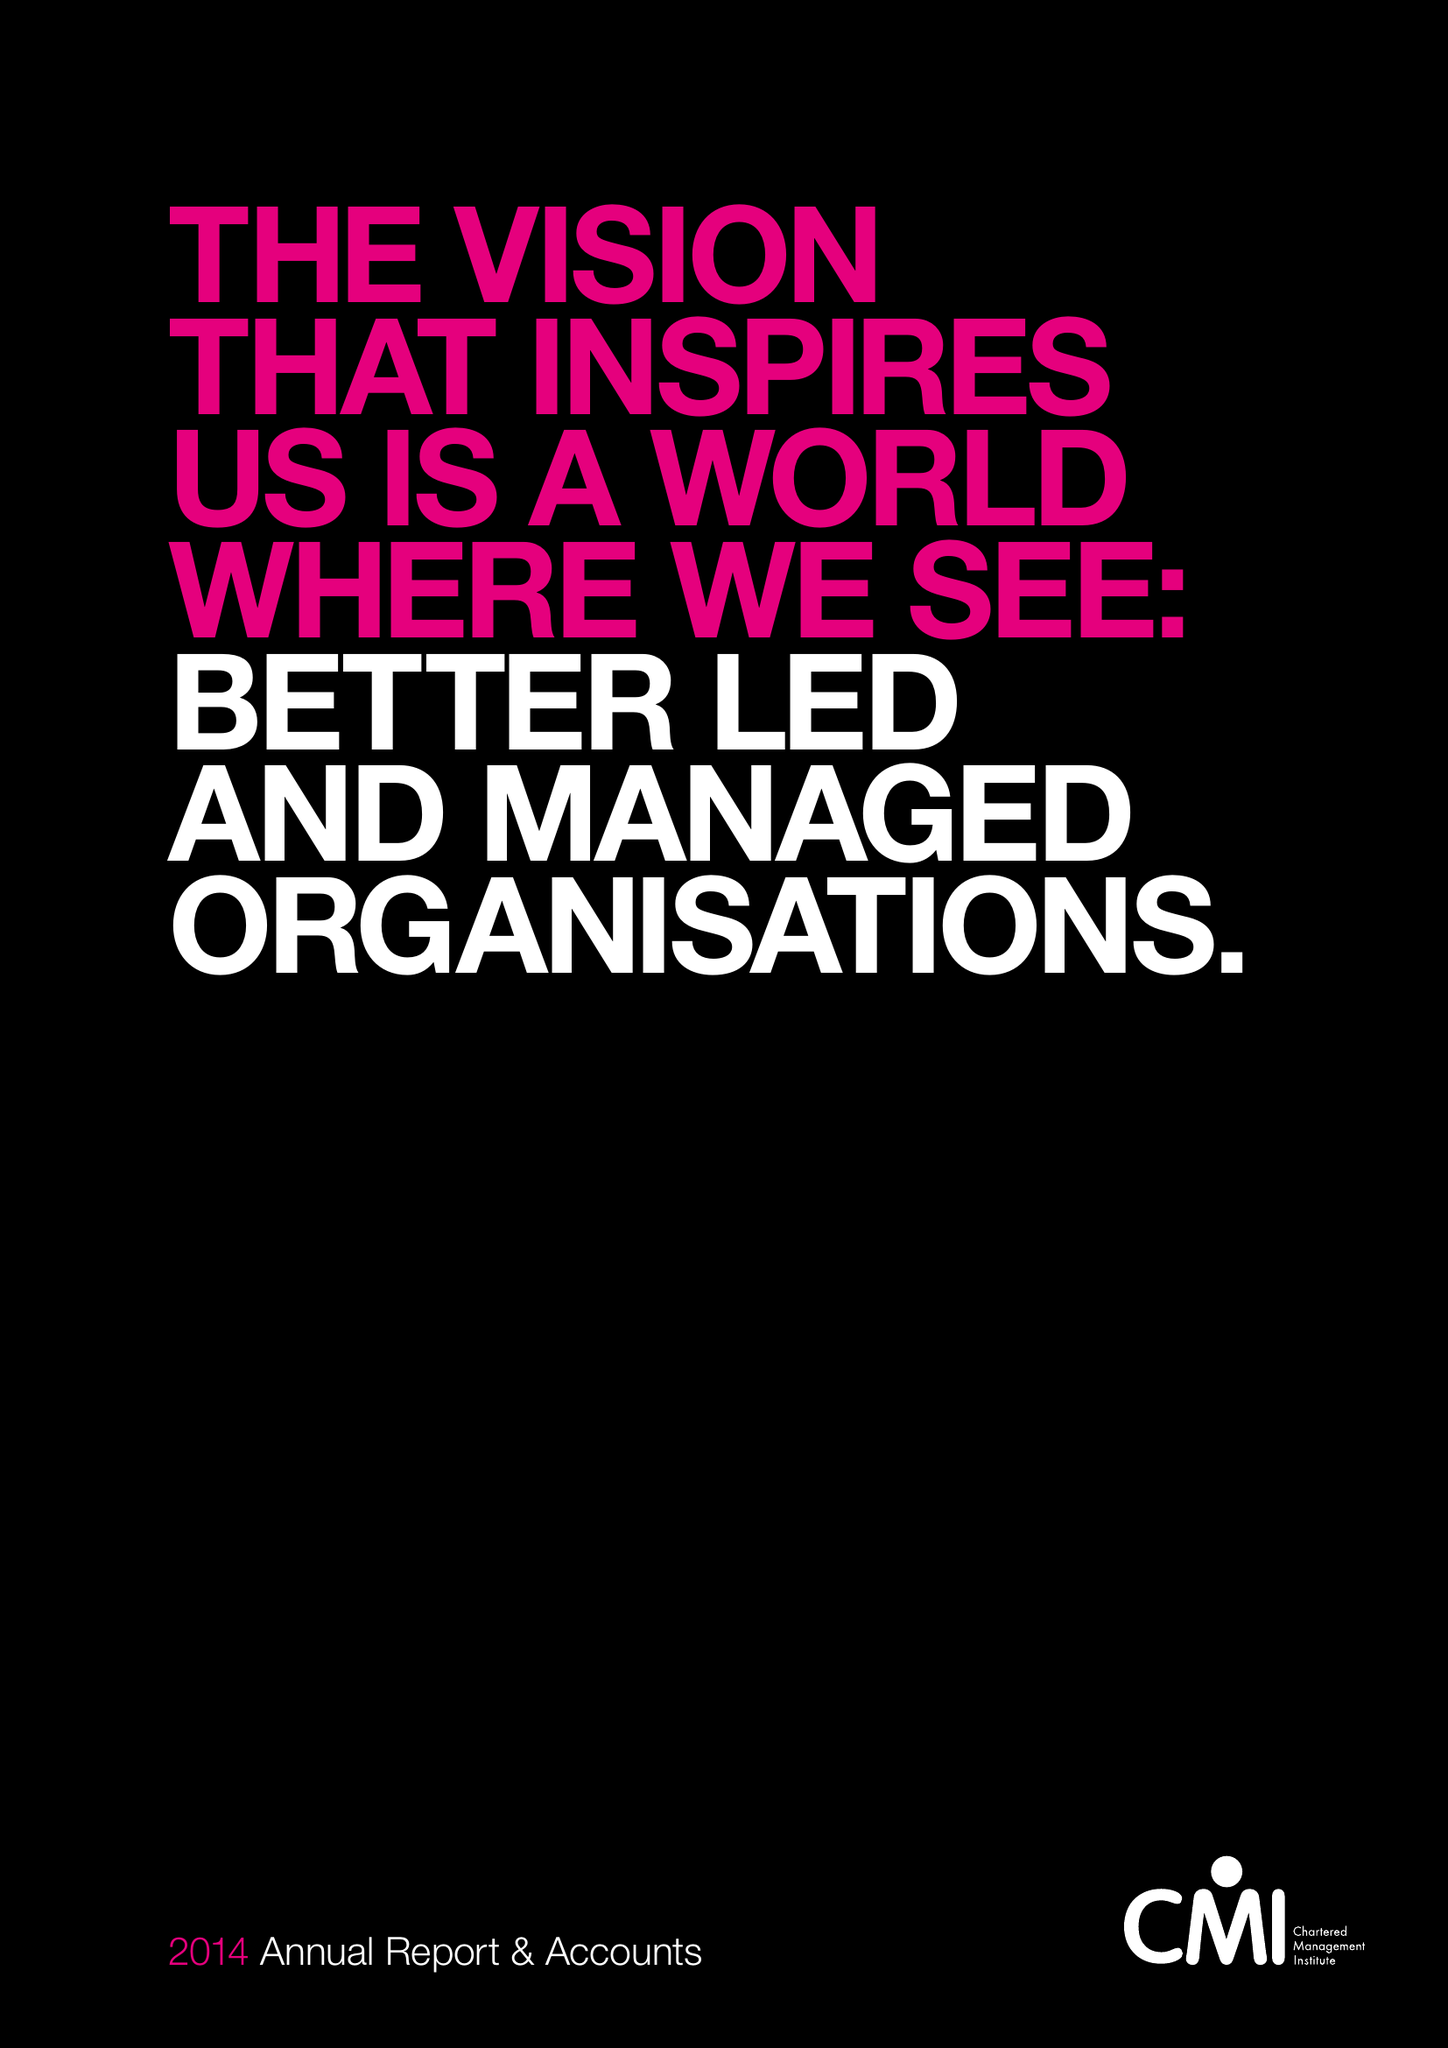What is the value for the income_annually_in_british_pounds?
Answer the question using a single word or phrase. 11033000.00 